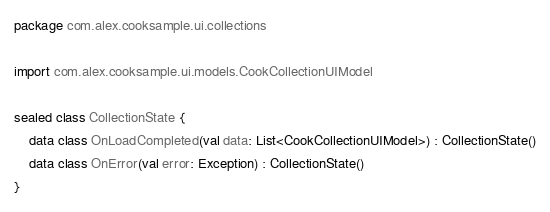<code> <loc_0><loc_0><loc_500><loc_500><_Kotlin_>package com.alex.cooksample.ui.collections

import com.alex.cooksample.ui.models.CookCollectionUIModel

sealed class CollectionState {
    data class OnLoadCompleted(val data: List<CookCollectionUIModel>) : CollectionState()
    data class OnError(val error: Exception) : CollectionState()
}</code> 